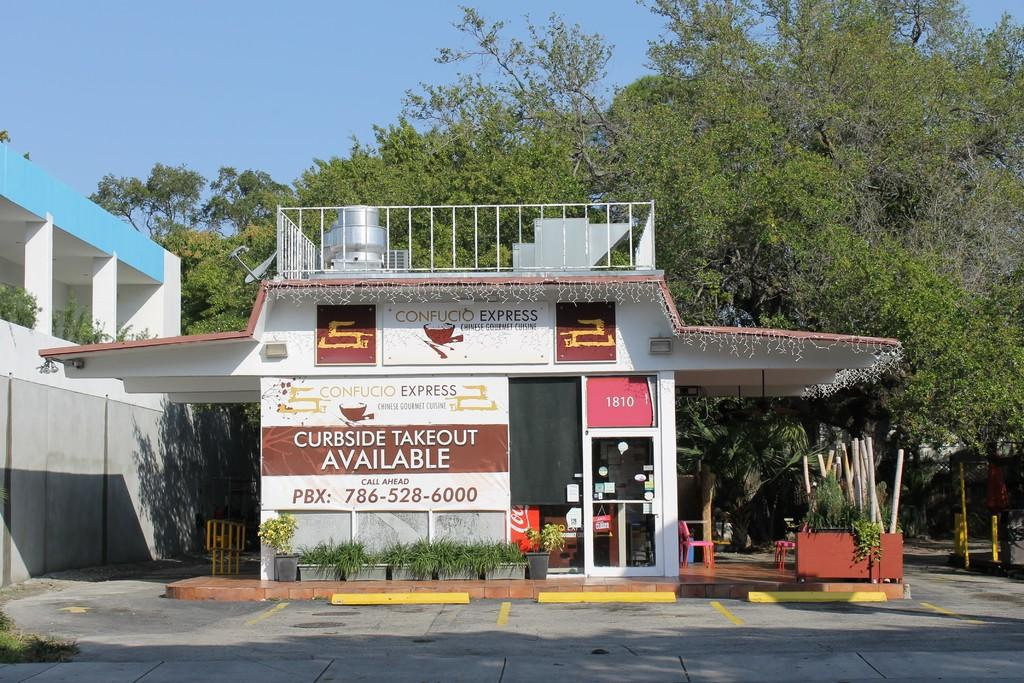What type of establishment is depicted in the image? There is a store with hoardings in the image. What can be seen in front of the store? There are plants in front of the store. What is visible in the background of the image? There are trees in the background of the image. What type of structure is shown in the image? The image depicts a building. What type of button is being used to increase the store's profit in the image? There is no button or mention of profit in the image; it simply shows a store with plants and trees in the background. 